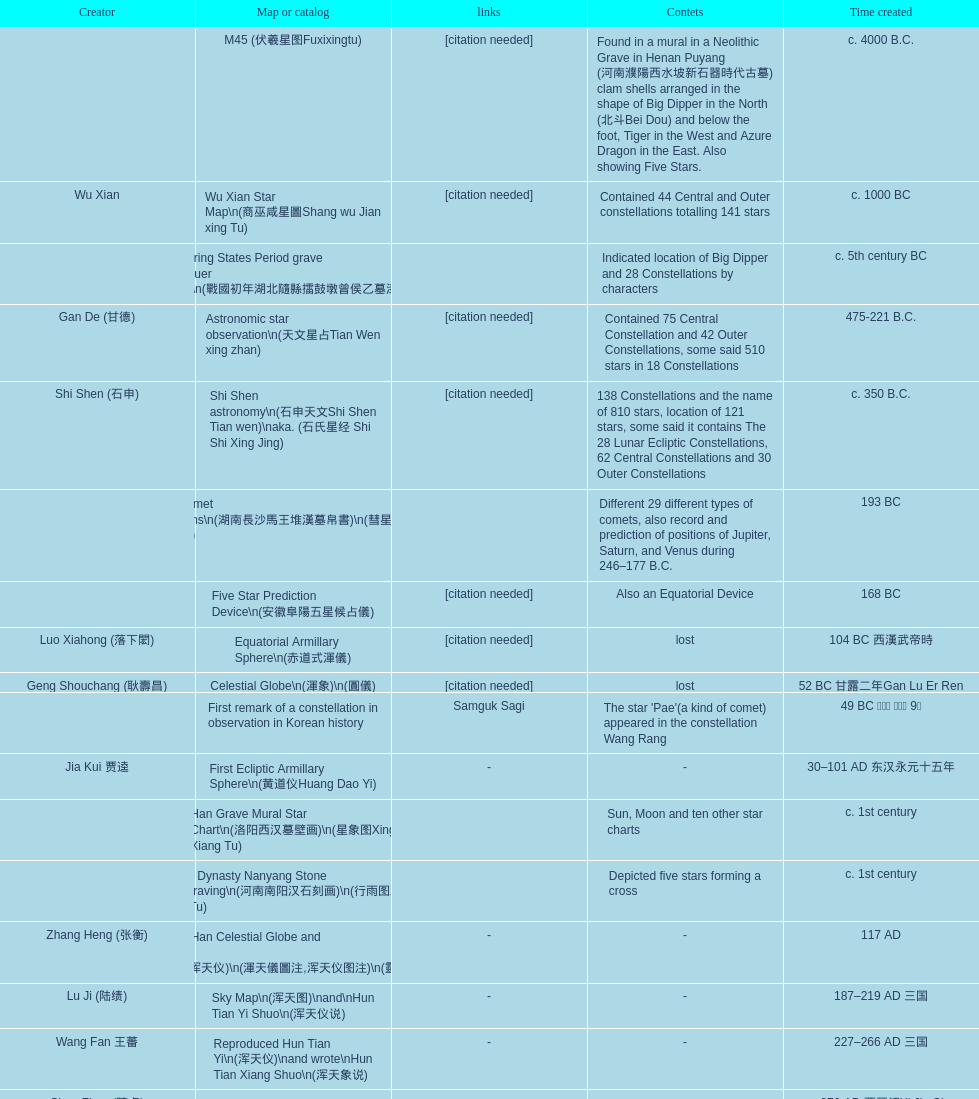Name three items created not long after the equatorial armillary sphere. Celestial Globe (渾象) (圓儀), First remark of a constellation in observation in Korean history, First Ecliptic Armillary Sphere (黄道仪Huang Dao Yi). Could you parse the entire table as a dict? {'header': ['Creator', 'Map or catalog', 'links', 'Contets', 'Time created'], 'rows': [['', 'M45 (伏羲星图Fuxixingtu)', '[citation needed]', 'Found in a mural in a Neolithic Grave in Henan Puyang (河南濮陽西水坡新石器時代古墓) clam shells arranged in the shape of Big Dipper in the North (北斗Bei Dou) and below the foot, Tiger in the West and Azure Dragon in the East. Also showing Five Stars.', 'c. 4000 B.C.'], ['Wu Xian', 'Wu Xian Star Map\\n(商巫咸星圖Shang wu Jian xing Tu)', '[citation needed]', 'Contained 44 Central and Outer constellations totalling 141 stars', 'c. 1000 BC'], ['', 'Warring States Period grave lacquer box\\n(戰國初年湖北隨縣擂鼓墩曾侯乙墓漆箱)', '', 'Indicated location of Big Dipper and 28 Constellations by characters', 'c. 5th century BC'], ['Gan De (甘德)', 'Astronomic star observation\\n(天文星占Tian Wen xing zhan)', '[citation needed]', 'Contained 75 Central Constellation and 42 Outer Constellations, some said 510 stars in 18 Constellations', '475-221 B.C.'], ['Shi Shen (石申)', 'Shi Shen astronomy\\n(石申天文Shi Shen Tian wen)\\naka. (石氏星经 Shi Shi Xing Jing)', '[citation needed]', '138 Constellations and the name of 810 stars, location of 121 stars, some said it contains The 28 Lunar Ecliptic Constellations, 62 Central Constellations and 30 Outer Constellations', 'c. 350 B.C.'], ['', 'Han Comet Diagrams\\n(湖南長沙馬王堆漢墓帛書)\\n(彗星圖Meng xing Tu)', '', 'Different 29 different types of comets, also record and prediction of positions of Jupiter, Saturn, and Venus during 246–177 B.C.', '193 BC'], ['', 'Five Star Prediction Device\\n(安徽阜陽五星候占儀)', '[citation needed]', 'Also an Equatorial Device', '168 BC'], ['Luo Xiahong (落下閎)', 'Equatorial Armillary Sphere\\n(赤道式渾儀)', '[citation needed]', 'lost', '104 BC 西漢武帝時'], ['Geng Shouchang (耿壽昌)', 'Celestial Globe\\n(渾象)\\n(圓儀)', '[citation needed]', 'lost', '52 BC 甘露二年Gan Lu Er Ren'], ['', 'First remark of a constellation in observation in Korean history', 'Samguk Sagi', "The star 'Pae'(a kind of comet) appeared in the constellation Wang Rang", '49 BC 혁거세 거서간 9년'], ['Jia Kui 贾逵', 'First Ecliptic Armillary Sphere\\n(黄道仪Huang Dao Yi)', '-', '-', '30–101 AD 东汉永元十五年'], ['', 'Han Grave Mural Star Chart\\n(洛阳西汉墓壁画)\\n(星象图Xing Xiang Tu)', '', 'Sun, Moon and ten other star charts', 'c. 1st century'], ['', 'Han Dynasty Nanyang Stone Engraving\\n(河南南阳汉石刻画)\\n(行雨图Xing Yu Tu)', '', 'Depicted five stars forming a cross', 'c. 1st century'], ['Zhang Heng (张衡)', 'Eastern Han Celestial Globe and star maps\\n(浑天仪)\\n(渾天儀圖注,浑天仪图注)\\n(靈憲,灵宪)', '-', '-', '117 AD'], ['Lu Ji (陆绩)', 'Sky Map\\n(浑天图)\\nand\\nHun Tian Yi Shuo\\n(浑天仪说)', '-', '-', '187–219 AD 三国'], ['Wang Fan 王蕃', 'Reproduced Hun Tian Yi\\n(浑天仪)\\nand wrote\\nHun Tian Xiang Shuo\\n(浑天象说)', '-', '-', '227–266 AD 三国'], ['Chen Zhuo (陳卓)', 'Whole Sky Star Maps\\n(全天星圖Quan Tian Xing Tu)', '-', 'A Unified Constellation System. Star maps containing 1464 stars in 284 Constellations, written astrology text', 'c. 270 AD 西晉初Xi Jin Chu'], ['Kong Ting (孔挺)', 'Equatorial Armillary Sphere\\n(渾儀Hun Xi)', '-', 'level being used in this kind of device', '323 AD 東晉 前趙光初六年'], ['Hu Lan (斛蘭)', 'Northern Wei Period Iron Armillary Sphere\\n(鐵渾儀)', '', '-', 'Bei Wei\\plevel being used in this kind of device'], ['Qian Lezhi (錢樂之)', 'Southern Dynasties Period Whole Sky Planetarium\\n(渾天象Hun Tian Xiang)', '-', 'used red, black and white to differentiate stars from different star maps from Shi Shen, Gan De and Wu Xian 甘, 石, 巫三家星', '443 AD 南朝劉宋元嘉年間'], ['', 'Northern Wei Grave Dome Star Map\\n(河南洛陽北魏墓頂星圖)', '', 'about 300 stars, including the Big Dipper, some stars are linked by straight lines to form constellation. The Milky Way is also shown.', '526 AD 北魏孝昌二年'], ['Geng Xun (耿詢)', 'Water-powered Planetarium\\n(水力渾天儀)', '-', '-', 'c. 7th century 隋初Sui Chu'], ['Yu Jicai (庾季才) and Zhou Fen (周墳)', 'Lingtai Miyuan\\n(靈台秘苑)', '-', 'incorporated star maps from different sources', '604 AD 隋Sui'], ['Li Chunfeng 李淳風', 'Tang Dynasty Whole Sky Ecliptic Armillary Sphere\\n(渾天黃道儀)', '-', 'including Elliptic and Moon orbit, in addition to old equatorial design', '667 AD 貞觀七年'], ['Dun Huang', 'The Dunhuang star map\\n(燉煌)', '', '1,585 stars grouped into 257 clusters or "asterisms"', '705–710 AD'], ['', 'Turfan Tomb Star Mural\\n(新疆吐鲁番阿斯塔那天文壁画)', '', '28 Constellations, Milkyway and Five Stars', '250–799 AD 唐'], ['', 'Picture of Fuxi and Nüwa 新疆阿斯達那唐墓伏羲Fu Xi 女媧NV Wa像Xiang', 'Image:Nuva fuxi.gif', 'Picture of Fuxi and Nuwa together with some constellations', 'Tang Dynasty'], ['Yixing Monk 一行和尚 (张遂)Zhang Sui and Liang Lingzan 梁令瓚', 'Tang Dynasty Armillary Sphere\\n(唐代渾儀Tang Dai Hun Xi)\\n(黃道遊儀Huang dao you xi)', '', 'based on Han Dynasty Celestial Globe, recalibrated locations of 150 stars, determined that stars are moving', '683–727 AD'], ['Yixing Priest 一行和尚 (张遂)\\pZhang Sui\\p683–727 AD', 'Tang Dynasty Indian Horoscope Chart\\n(梵天火羅九曜)', '', '', 'simple diagrams of the 28 Constellation'], ['', 'Kitora Kofun 法隆寺FaLong Si\u3000キトラ古墳 in Japan', '', 'Detailed whole sky map', 'c. late 7th century – early 8th century'], ['Gautama Siddha', 'Treatise on Astrology of the Kaiyuan Era\\n(開元占経,开元占经Kai Yuan zhang Jing)', '-', 'Collection of the three old star charts from Shi Shen, Gan De and Wu Xian. One of the most renowned collection recognized academically.', '713 AD –'], ['', 'Big Dipper\\n(山東嘉祥武梁寺石刻北斗星)', '', 'showing stars in Big Dipper', '–'], ['', 'Prajvalonisa Vjrabhairava Padvinasa-sri-dharani Scroll found in Japan 熾盛光佛頂大威德銷災吉祥陀羅尼經卷首扉畫', '-', 'Chinese 28 Constellations and Western Zodiac', '972 AD 北宋開寶五年'], ['', 'Tangut Khara-Khoto (The Black City) Star Map 西夏黑水城星圖', '-', 'A typical Qian Lezhi Style Star Map', '940 AD'], ['', 'Star Chart 五代吳越文穆王前元瓘墓石刻星象圖', '', '-', '941–960 AD'], ['', 'Ancient Star Map 先天图 by 陈抟Chen Tuan', 'Lost', 'Perhaps based on studying of Puyong Ancient Star Map', 'c. 11th Chen Tuan 宋Song'], ['Han Xianfu 韓顯符', 'Song Dynasty Bronze Armillary Sphere 北宋至道銅渾儀', '-', 'Similar to the Simplified Armillary by Kong Ting 孔挺, 晁崇 Chao Chong, 斛蘭 Hu Lan', '1006 AD 宋道元年十二月'], ['Shu Yijian 舒易簡, Yu Yuan 于渊, Zhou Cong 周琮', 'Song Dynasty Bronze Armillary Sphere 北宋天文院黄道渾儀', '-', 'Similar to the Armillary by Tang Dynasty Liang Lingzan 梁令瓚 and Yi Xing 一行', '宋皇祐年中'], ['Shen Kuo 沈括 and Huangfu Yu 皇甫愈', 'Song Dynasty Armillary Sphere 北宋簡化渾儀', '-', 'Simplied version of Tang Dynasty Device, removed the rarely used moon orbit.', '1089 AD 熙寧七年'], ['Su Song 蘇頌', 'Five Star Charts (新儀象法要)', 'Image:Su Song Star Map 1.JPG\\nImage:Su Song Star Map 2.JPG', '1464 stars grouped into 283 asterisms', '1094 AD'], ['Su Song 蘇頌 and Han Gonglian 韩公廉', 'Song Dynasty Water-powered Planetarium 宋代 水运仪象台', '', '-', 'c. 11th century'], ['', 'Liao Dynasty Tomb Dome Star Map 遼宣化张世卿墓頂星圖', '', 'shown both the Chinese 28 Constellation encircled by Babylonian Zodiac', '1116 AD 遼天庆六年'], ['', "Star Map in a woman's grave (江西德安 南宋周氏墓星相图)", '', 'Milky Way and 57 other stars.', '1127–1279 AD'], ['Huang Shang (黃裳)', 'Hun Tian Yi Tong Xing Xiang Quan Tu, Suzhou Star Chart (蘇州石刻天文圖),淳祐天文図', '', '1434 Stars grouped into 280 Asterisms in Northern Sky map', 'created in 1193, etched to stone in 1247 by Wang Zhi Yuan 王致遠'], ['Guo Shou Jing 郭守敬', 'Yuan Dynasty Simplified Armillary Sphere 元代簡儀', '', 'Further simplied version of Song Dynasty Device', '1276–1279'], ['', 'Japanese Star Chart 格子月進図', '', 'Similar to Su Song Star Chart, original burned in air raids during World War II, only pictures left. Reprinted in 1984 by 佐佐木英治', '1324'], ['', '天象列次分野之図(Cheonsang Yeolcha Bunyajido)', '', 'Korean versions of Star Map in Stone. It was made in Chosun Dynasty and the constellation names were written in Chinese letter. The constellations as this was found in Japanese later. Contained 1,464 stars.', '1395'], ['', 'Japanese Star Chart 瀧谷寺 天之図', '', '-', 'c. 14th or 15th centuries 室町中期以前'], ['', "Korean King Sejong's Armillary sphere", '', '-', '1433'], ['Mao Kun 茅坤', 'Star Chart', 'zh:郑和航海图', 'Polaris compared with Southern Cross and Alpha Centauri', 'c. 1422'], ['', 'Korean Tomb', '', 'Big Dipper', 'c. late 14th century'], ['', 'Ming Ancient Star Chart 北京隆福寺(古星圖)', '', '1420 Stars, possibly based on old star maps from Tang Dynasty', 'c. 1453 明代'], ['', 'Chanshu Star Chart (明常熟石刻天文圖)', '-', 'Based on Suzhou Star Chart, Northern Sky observed at 36.8 degrees North Latitude, 1466 stars grouped into 284 asterism', '1506'], ['Matteo Ricci 利玛窦Li Ma Dou, recorded by Li Zhizao 李之藻', 'Ming Dynasty Star Map (渾蓋通憲圖說)', '', '-', 'c. 1550'], ['Xiao Yun Cong 萧云从', 'Tian Wun Tu (天问图)', '', 'Contained mapping of 12 constellations and 12 animals', 'c. 1600'], ['by 尹真人高第弟子 published by 余永宁', 'Zhou Tian Xuan Ji Tu (周天璇玑图) and He He Si Xiang Tu (和合四象圖) in Xing Ming Gui Zhi (性命圭旨)', '', 'Drawings of Armillary Sphere and four Chinese Celestial Animals with some notes. Related to Taoism.', '1615'], ['', 'Korean Astronomy Book "Selected and Systematized Astronomy Notes" 天文類抄', '', 'Contained some star maps', '1623~1649'], ['Xu Guang ci 徐光啟 and Adam Schall von Bell Tang Ruo Wang湯若望', 'Ming Dynasty General Star Map (赤道南北兩總星圖)', '', '-', '1634'], ['Xu Guang ci 徐光啟', 'Ming Dynasty diagrams of Armillary spheres and Celestial Globes', '', '-', 'c. 1699'], ['', 'Ming Dynasty Planetarium Machine (渾象 Hui Xiang)', '', 'Ecliptic, Equator, and dividers of 28 constellation', 'c. 17th century'], ['', 'Copper Plate Star Map stored in Korea', '', '-', '1652 順治九年shun zi jiu nian'], ['Harumi Shibukawa 渋川春海Bu Chuan Chun Mei(保井春海Bao Jing Chun Mei)', 'Japanese Edo period Star Chart 天象列次之図 based on 天象列次分野之図 from Korean', '', '-', '1670 寛文十年'], ['Ferdinand Verbiest 南懷仁', 'The Celestial Globe 清康熙 天體儀', '', '1876 stars grouped into 282 asterisms', '1673'], ['Japanese painter', 'Picture depicted Song Dynasty fictional astronomer (呉用 Wu Yong) with a Celestial Globe (天體儀)', 'File:Chinese astronomer 1675.jpg', 'showing top portion of a Celestial Globe', '1675'], ['Harumi Shibukawa 渋川春海BuJingChun Mei (保井春海Bao JingChunMei)', 'Japanese Edo period Star Chart 天文分野之図', '', '-', '1677 延宝五年'], ['', 'Korean star map in stone', '', '-', '1687'], ['井口常範', 'Japanese Edo period Star Chart 天文図解', '-', '-', '1689 元禄2年'], ['苗村丈伯Mao Chun Zhang Bo', 'Japanese Edo period Star Chart 古暦便覧備考', '-', '-', '1692 元禄5年'], ['Harumi Yasui written in Chinese', 'Japanese star chart', '', 'A Japanese star chart of 1699 showing lunar stations', '1699 AD'], ['(渋川昔尹She Chuan Xi Yin) (保井昔尹Bao Jing Xi Yin)', 'Japanese Edo period Star Chart 天文成象Tian Wen Cheng xiang', '', 'including Stars from Wu Shien (44 Constellation, 144 stars) in yellow; Gan De (118 Constellations, 511 stars) in black; Shi Shen (138 Constellations, 810 stars) in red and Harumi Shibukawa (61 Constellations, 308 stars) in blue;', '1699 元禄十二年'], ['', 'Japanese Star Chart 改正天文図説', '', 'Included stars from Harumi Shibukawa', 'unknown'], ['', 'Korean Star Map Stone', '', '-', 'c. 17th century'], ['', 'Korean Star Map', '', '-', 'c. 17th century'], ['', 'Ceramic Ink Sink Cover', '', 'Showing Big Dipper', 'c. 17th century'], ['Italian Missionary Philippus Maria Grimardi 閔明我 (1639~1712)', 'Korean Star Map Cube 方星圖', '', '-', 'c. early 18th century'], ['You Zi liu 游子六', 'Star Chart preserved in Japan based on a book from China 天経或問', '', 'A Northern Sky Chart in Chinese', '1730 AD 江戸時代 享保15年'], ['', 'Star Chart 清蒙文石刻(欽天監繪製天文圖) in Mongolia', '', '1550 stars grouped into 270 starisms.', '1727–1732 AD'], ['', 'Korean Star Maps, North and South to the Eclliptic 黃道南北恒星圖', '', '-', '1742'], ['入江脩敬Ru Jiang YOu Jing', 'Japanese Edo period Star Chart 天経或問註解図巻\u3000下', '-', '-', '1750 寛延3年'], ['Dai Zhen 戴震', 'Reproduction of an ancient device 璇璣玉衡', 'Could be similar to', 'based on ancient record and his own interpretation', '1723–1777 AD'], ['', 'Rock Star Chart 清代天文石', '', 'A Star Chart and general Astronomy Text', 'c. 18th century'], ['', 'Korean Complete Star Map (渾天全圖)', '', '-', 'c. 18th century'], ['Yun Lu 允禄 and Ignatius Kogler 戴进贤Dai Jin Xian 戴進賢, a German', 'Qing Dynasty Star Catalog (儀象考成,仪象考成)恒星表 and Star Map 黄道南北両星総図', '', '300 Constellations and 3083 Stars. Referenced Star Catalogue published by John Flamsteed', 'Device made in 1744, book completed in 1757 清乾隆年间'], ['', 'Jingban Tianwen Quantu by Ma Junliang 马俊良', '', 'mapping nations to the sky', '1780–90 AD'], ['Yan Qiao Shan Bing Heng 岩橋善兵衛', 'Japanese Edo period Illustration of a Star Measuring Device 平天儀図解', 'The device could be similar to', '-', '1802 Xiang He Er Nian 享和二年'], ['Xu Choujun 徐朝俊', 'North Sky Map 清嘉庆年间Huang Dao Zhong Xi He Tu(黄道中西合图)', '', 'More than 1000 stars and the 28 consellation', '1807 AD'], ['Chao Ye Bei Shui 朝野北水', 'Japanese Edo period Star Chart 天象総星之図', '-', '-', '1814 文化十一年'], ['田中政均', 'Japanese Edo period Star Chart 新制天球星象記', '-', '-', '1815 文化十二年'], ['坂部廣胖', 'Japanese Edo period Star Chart 天球図', '-', '-', '1816 文化十三年'], ['John Reeves esq', 'Chinese Star map', '', 'Printed map showing Chinese names of stars and constellations', '1819 AD'], ['佐藤祐之', 'Japanese Edo period Star Chart 昊天図説詳解', '-', '-', '1824 文政七年'], ['小島好謙 and 鈴木世孝', 'Japanese Edo period Star Chart 星図歩天歌', '-', '-', '1824 文政七年'], ['鈴木世孝', 'Japanese Edo period Star Chart', '-', '-', '1824 文政七年'], ['長久保赤水', 'Japanese Edo period Star Chart 天象管鈔 天体図 (天文星象図解)', '', '-', '1824 文政七年'], ['足立信順Zhu Li Xin Shun', 'Japanese Edo period Star Measuring Device 中星儀', '-', '-', '1824 文政七年'], ['桜田虎門', 'Japanese Star Map 天象一覧図 in Kanji', '', 'Printed map showing Chinese names of stars and constellations', '1824 AD 文政７年'], ['', 'Korean Star Map 天象列次分野之図 in Kanji', '[18]', 'Printed map showing Chinese names of stars and constellations', 'c. 19th century'], ['', 'Korean Star Map', '', '-', 'c. 19th century, late Choson Period'], ['', 'Korean Star maps: Star Map South to the Ecliptic 黃道南恒星圖 and Star Map South to the Ecliptic 黃道北恒星圖', '', 'Perhaps influenced by Adam Schall von Bell Tang Ruo wang 湯若望 (1591–1666) and P. Ignatius Koegler 戴進賢 (1680–1748)', 'c. 19th century'], ['', 'Korean Complete map of the celestial sphere (渾天全圖)', '', '-', 'c. 19th century'], ['', 'Korean Book of Stars 經星', '', 'Several star maps', 'c. 19th century'], ['石坂常堅', 'Japanese Edo period Star Chart 方円星図,方圓星図 and 増補分度星図方図', '-', '-', '1826b文政9年'], ['伊能忠誨', 'Japanese Star Chart', '-', '-', 'c. 19th century'], ['古筆源了材', 'Japanese Edo period Star Chart 天球図説', '-', '-', '1835 天保6年'], ['', 'Qing Dynasty Star Catalog (儀象考成續編)星表', '', 'Appendix to Yi Xian Kao Cheng, listed 3240 stars (added 163, removed 6)', '1844'], ['', 'Stars map (恒星赤道経緯度図)stored in Japan', '-', '-', '1844 道光24年 or 1848'], ['藤岡有貞', 'Japanese Edo period Star Chart 経緯簡儀用法', '-', '-', '1845 弘化２年'], ['高塚福昌, 阿部比輔, 上条景弘', 'Japanese Edo period Star Chart 分野星図', '-', '-', '1849 嘉永2年'], ['遠藤盛俊', 'Japanese Late Edo period Star Chart 天文図屏風', '-', '-', 'late Edo Period 江戸時代後期'], ['三浦梅園', 'Japanese Star Chart 天体図', '-', '-', '-'], ['高橋景保', 'Japanese Star Chart 梅園星図', '', '-', '-'], ['李俊養', 'Korean Book of New Song of the Sky Pacer 新法步天歌', '', 'Star maps and a revised version of the Song of Sky Pacer', '1862'], ['', 'Stars South of Equator, Stars North of Equator (赤道南恆星圖,赤道北恆星圖)', '', 'Similar to Ming Dynasty General Star Map', '1875～1908 清末光緒年間'], ['', 'Fuxi 64 gua 28 xu wood carving 天水市卦台山伏羲六十四卦二十八宿全图', '-', '-', 'modern'], ['', 'Korean Map of Heaven and Earth 天地圖', '', '28 Constellations and geographic map', 'c. 19th century'], ['', 'Korean version of 28 Constellation 列宿圖', '', '28 Constellations, some named differently from their Chinese counterparts', 'c. 19th century'], ['朴?', 'Korean Star Chart 渾天図', '-', '-', '-'], ['', 'Star Chart in a Dao Temple 玉皇山道觀星圖', '-', '-', '1940 AD'], ['Yi Shi Tong 伊世同', 'Simplified Chinese and Western Star Map', '', 'Star Map showing Chinese Xingquan and Western Constellation boundaries', 'Aug. 1963'], ['Yu Xi Dao Ren 玉溪道人', 'Sky Map', '', 'Star Map with captions', '1987'], ['Sun Xiaochun and Jacob Kistemaker', 'The Chinese Sky during the Han Constellating Stars and Society', '', 'An attempt to recreate night sky seen by Chinese 2000 years ago', '1997 AD'], ['', 'Star map', '', 'An attempt by a Japanese to reconstruct the night sky for a historical event around 235 AD 秋風五丈原', 'Recent'], ['', 'Star maps', '', 'Chinese 28 Constellation with Chinese and Japanese captions', 'Recent'], ['', 'SinoSky Beta 2.0', '', 'A computer program capable of showing Chinese Xingguans alongside with western constellations, lists about 700 stars with Chinese names.', '2002'], ['', 'AEEA Star maps', '', 'Good reconstruction and explanation of Chinese constellations', 'Modern'], ['', 'Wikipedia Star maps', 'zh:華蓋星', '-', 'Modern'], ['', '28 Constellations, big dipper and 4 symbols Star map', '', '-', 'Modern'], ['', 'Collection of printed star maps', '', '-', 'Modern'], ['-', '28 Xu Star map and catalog', '', 'Stars around ecliptic', 'Modern'], ['Jeong, Tae-Min(jtm71)/Chuang_Siau_Chin', 'HNSKY Korean/Chinese Supplement', '', 'Korean supplement is based on CheonSangYeulChaBunYaZiDo (B.C.100 ~ A.D.100)', 'Modern'], ['G.S.K. Lee; Jeong, Tae-Min(jtm71); Yu-Pu Wang (evanzxcv)', 'Stellarium Chinese and Korean Sky Culture', '', 'Major Xingguans and Star names', 'Modern'], ['Xi Chun Sheng Chong Hui\\p2005 redrawn, original unknown', '修真內外火侯全圖 Huo Hou Tu', '', '', 'illustrations of Milkyway and star maps, Chinese constellations in Taoism view'], ['坐井★观星Zuo Jing Guan Xing', 'Star Map with illustrations for Xingguans', '', 'illustrations for cylindrical and circular polar maps', 'Modern'], ['', 'Sky in Google Earth KML', '', 'Attempts to show Chinese Star Maps on Google Earth', 'Modern']]} 